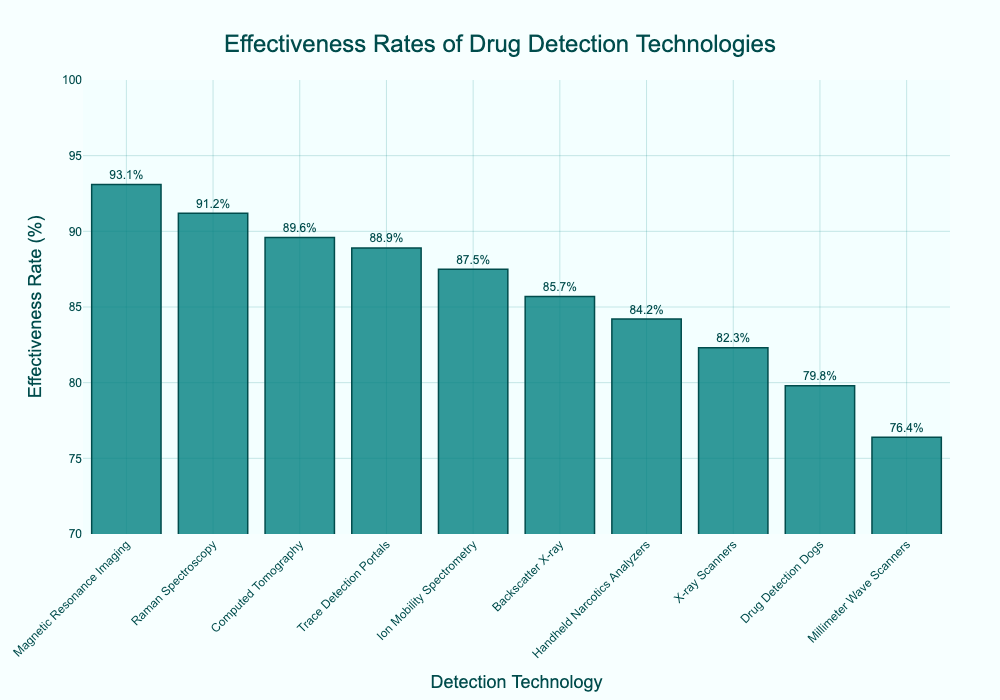Which drug detection technology has the highest effectiveness rate? By examining the top of the bars in the figure, we can see that Magnetic Resonance Imaging has the highest effectiveness rate.
Answer: Magnetic Resonance Imaging How many technologies have an effectiveness rate above 90%? Counting the bars that extend higher than the 90% mark, we see that there are three technologies: Magnetic Resonance Imaging, Raman Spectroscopy, and Computed Tomography.
Answer: Three What is the effectiveness rate of Drug Detection Dogs compared to Handheld Narcotics Analyzers? By comparing the height of the bars, Drug Detection Dogs have an effectiveness rate of 79.8%, while Handheld Narcotics Analyzers have an effectiveness rate of 84.2%.
Answer: Handheld Narcotics Analyzers have a higher effectiveness rate What is the difference in effectiveness rate between the least and the most effective technologies? The least effective technology is Millimeter Wave Scanners with 76.4%, and the most effective is Magnetic Resonance Imaging with 93.1%. The difference is 93.1% - 76.4% = 16.7%.
Answer: 16.7% Which technology is just below Handheld Narcotics Analyzers in effectiveness rate? In the sorted figure, the bar just below Handheld Narcotics Analyzers (84.2%) belongs to Backscatter X-ray with an effectiveness rate of 85.7%.
Answer: Backscatter X-ray What is the average effectiveness rate of all technologies listed? Summing all effectiveness rates (87.5 + 82.3 + 79.8 + 91.2 + 76.4 + 85.7 + 88.9 + 93.1 + 89.6 + 84.2 = 859.7) and dividing by the number of technologies (10) yields 859.7 / 10 = 85.97%.
Answer: 85.97% Which two technologies have the closest effectiveness rates? By checking the adjacent heights of the bars, Ion Mobility Spectrometry (87.5%) and Backscatter X-ray (85.7%) have a small difference of 1.8 percentage points.
Answer: Ion Mobility Spectrometry and Backscatter X-ray What is the effectiveness rate of the third most effective technology? The third highest bar belongs to Computed Tomography with an effectiveness rate of 89.6%.
Answer: Computed Tomography has an effectiveness rate of 89.6% 